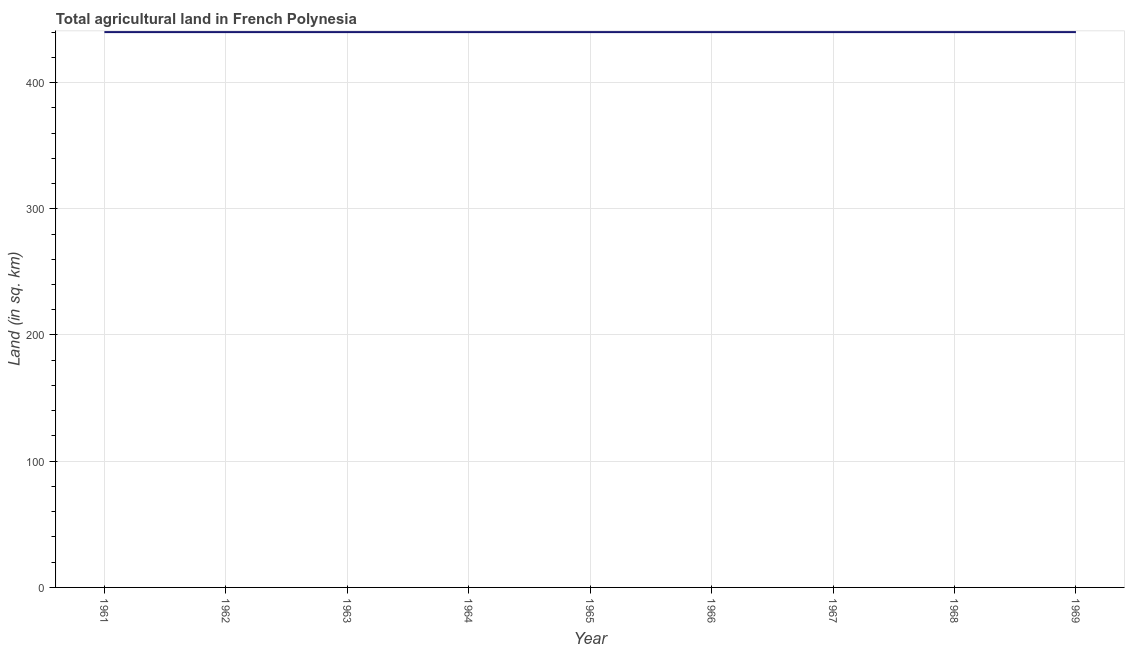What is the agricultural land in 1966?
Your answer should be compact. 440. Across all years, what is the maximum agricultural land?
Offer a terse response. 440. Across all years, what is the minimum agricultural land?
Your answer should be very brief. 440. In which year was the agricultural land maximum?
Offer a very short reply. 1961. In which year was the agricultural land minimum?
Your answer should be very brief. 1961. What is the sum of the agricultural land?
Provide a short and direct response. 3960. What is the difference between the agricultural land in 1964 and 1966?
Provide a succinct answer. 0. What is the average agricultural land per year?
Provide a succinct answer. 440. What is the median agricultural land?
Offer a terse response. 440. In how many years, is the agricultural land greater than 160 sq. km?
Provide a short and direct response. 9. Do a majority of the years between 1967 and 1969 (inclusive) have agricultural land greater than 200 sq. km?
Offer a very short reply. Yes. Is the sum of the agricultural land in 1967 and 1969 greater than the maximum agricultural land across all years?
Your answer should be very brief. Yes. How many years are there in the graph?
Ensure brevity in your answer.  9. What is the title of the graph?
Your answer should be very brief. Total agricultural land in French Polynesia. What is the label or title of the Y-axis?
Make the answer very short. Land (in sq. km). What is the Land (in sq. km) of 1961?
Give a very brief answer. 440. What is the Land (in sq. km) in 1962?
Provide a succinct answer. 440. What is the Land (in sq. km) in 1963?
Keep it short and to the point. 440. What is the Land (in sq. km) in 1964?
Offer a terse response. 440. What is the Land (in sq. km) of 1965?
Make the answer very short. 440. What is the Land (in sq. km) in 1966?
Ensure brevity in your answer.  440. What is the Land (in sq. km) of 1967?
Your response must be concise. 440. What is the Land (in sq. km) of 1968?
Provide a short and direct response. 440. What is the Land (in sq. km) in 1969?
Ensure brevity in your answer.  440. What is the difference between the Land (in sq. km) in 1961 and 1963?
Make the answer very short. 0. What is the difference between the Land (in sq. km) in 1961 and 1964?
Make the answer very short. 0. What is the difference between the Land (in sq. km) in 1961 and 1966?
Your answer should be very brief. 0. What is the difference between the Land (in sq. km) in 1961 and 1968?
Give a very brief answer. 0. What is the difference between the Land (in sq. km) in 1961 and 1969?
Ensure brevity in your answer.  0. What is the difference between the Land (in sq. km) in 1962 and 1964?
Ensure brevity in your answer.  0. What is the difference between the Land (in sq. km) in 1962 and 1967?
Your response must be concise. 0. What is the difference between the Land (in sq. km) in 1962 and 1969?
Give a very brief answer. 0. What is the difference between the Land (in sq. km) in 1963 and 1964?
Make the answer very short. 0. What is the difference between the Land (in sq. km) in 1963 and 1965?
Give a very brief answer. 0. What is the difference between the Land (in sq. km) in 1963 and 1966?
Offer a terse response. 0. What is the difference between the Land (in sq. km) in 1963 and 1967?
Keep it short and to the point. 0. What is the difference between the Land (in sq. km) in 1963 and 1968?
Offer a very short reply. 0. What is the difference between the Land (in sq. km) in 1963 and 1969?
Give a very brief answer. 0. What is the difference between the Land (in sq. km) in 1964 and 1965?
Ensure brevity in your answer.  0. What is the difference between the Land (in sq. km) in 1964 and 1966?
Offer a very short reply. 0. What is the difference between the Land (in sq. km) in 1964 and 1967?
Give a very brief answer. 0. What is the difference between the Land (in sq. km) in 1964 and 1968?
Ensure brevity in your answer.  0. What is the difference between the Land (in sq. km) in 1964 and 1969?
Offer a terse response. 0. What is the difference between the Land (in sq. km) in 1965 and 1966?
Your response must be concise. 0. What is the difference between the Land (in sq. km) in 1965 and 1968?
Your answer should be compact. 0. What is the difference between the Land (in sq. km) in 1966 and 1968?
Keep it short and to the point. 0. What is the difference between the Land (in sq. km) in 1967 and 1968?
Your answer should be very brief. 0. What is the difference between the Land (in sq. km) in 1968 and 1969?
Offer a very short reply. 0. What is the ratio of the Land (in sq. km) in 1961 to that in 1966?
Give a very brief answer. 1. What is the ratio of the Land (in sq. km) in 1962 to that in 1963?
Keep it short and to the point. 1. What is the ratio of the Land (in sq. km) in 1962 to that in 1965?
Your response must be concise. 1. What is the ratio of the Land (in sq. km) in 1962 to that in 1967?
Offer a very short reply. 1. What is the ratio of the Land (in sq. km) in 1962 to that in 1968?
Provide a succinct answer. 1. What is the ratio of the Land (in sq. km) in 1962 to that in 1969?
Make the answer very short. 1. What is the ratio of the Land (in sq. km) in 1963 to that in 1964?
Your response must be concise. 1. What is the ratio of the Land (in sq. km) in 1963 to that in 1965?
Provide a succinct answer. 1. What is the ratio of the Land (in sq. km) in 1963 to that in 1967?
Make the answer very short. 1. What is the ratio of the Land (in sq. km) in 1964 to that in 1966?
Ensure brevity in your answer.  1. What is the ratio of the Land (in sq. km) in 1964 to that in 1967?
Make the answer very short. 1. What is the ratio of the Land (in sq. km) in 1964 to that in 1968?
Your response must be concise. 1. What is the ratio of the Land (in sq. km) in 1964 to that in 1969?
Offer a terse response. 1. What is the ratio of the Land (in sq. km) in 1965 to that in 1967?
Your response must be concise. 1. What is the ratio of the Land (in sq. km) in 1966 to that in 1967?
Make the answer very short. 1. What is the ratio of the Land (in sq. km) in 1966 to that in 1968?
Offer a very short reply. 1. What is the ratio of the Land (in sq. km) in 1967 to that in 1968?
Give a very brief answer. 1. What is the ratio of the Land (in sq. km) in 1967 to that in 1969?
Provide a short and direct response. 1. 